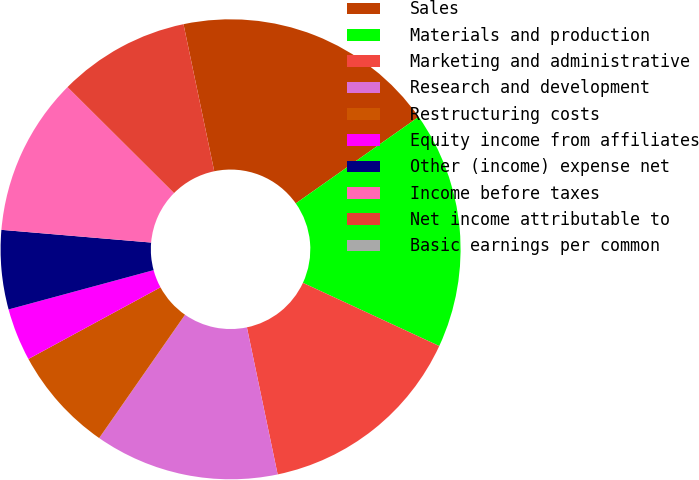Convert chart to OTSL. <chart><loc_0><loc_0><loc_500><loc_500><pie_chart><fcel>Sales<fcel>Materials and production<fcel>Marketing and administrative<fcel>Research and development<fcel>Restructuring costs<fcel>Equity income from affiliates<fcel>Other (income) expense net<fcel>Income before taxes<fcel>Net income attributable to<fcel>Basic earnings per common<nl><fcel>18.52%<fcel>16.67%<fcel>14.81%<fcel>12.96%<fcel>7.41%<fcel>3.7%<fcel>5.56%<fcel>11.11%<fcel>9.26%<fcel>0.0%<nl></chart> 